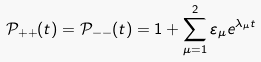<formula> <loc_0><loc_0><loc_500><loc_500>\mathcal { P } _ { + + } ( t ) = \mathcal { P } _ { - - } ( t ) = 1 + \sum _ { \mu = 1 } ^ { 2 } \varepsilon _ { \mu } e ^ { \lambda _ { \mu } t }</formula> 